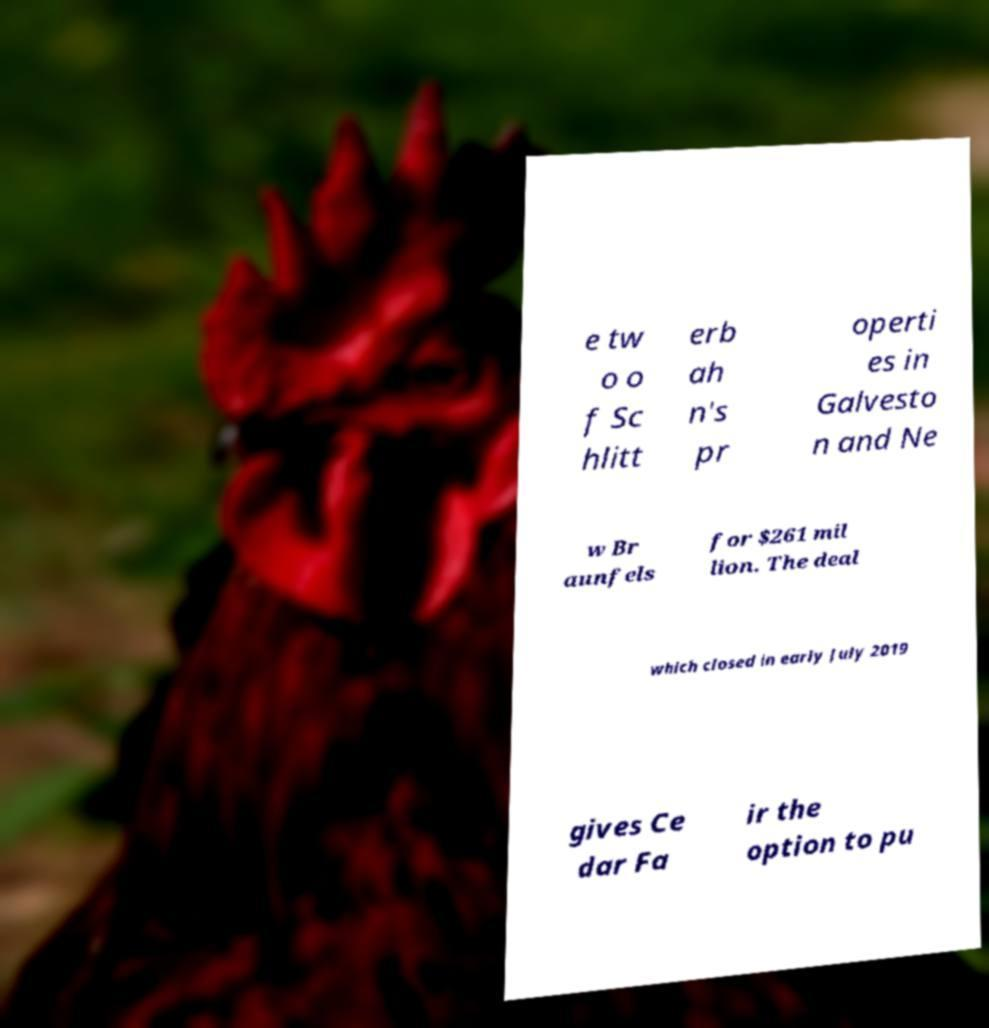Can you read and provide the text displayed in the image?This photo seems to have some interesting text. Can you extract and type it out for me? e tw o o f Sc hlitt erb ah n's pr operti es in Galvesto n and Ne w Br aunfels for $261 mil lion. The deal which closed in early July 2019 gives Ce dar Fa ir the option to pu 